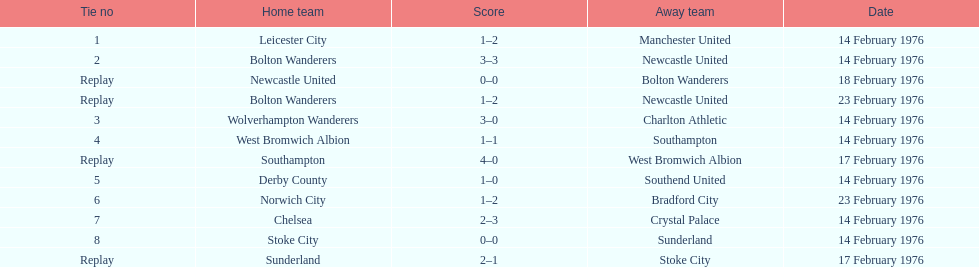What is the number of games sunderland has played as mentioned here? 2. 